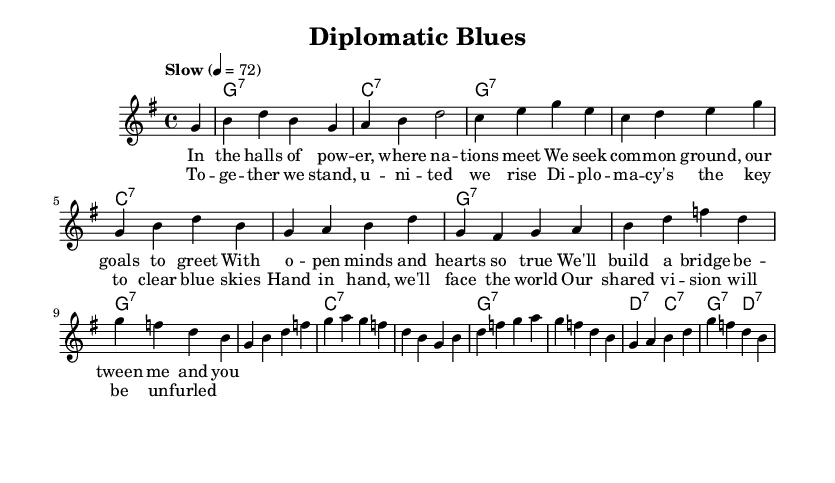What is the key signature of this music? The key signature is G major, which has one sharp (F#). You can determine this from the `\key g \major` command in the code.
Answer: G major What is the time signature of this music? The time signature is 4/4, indicated by the `\time 4/4` command in the notation. This means there are four beats per measure and the quarter note gets one beat.
Answer: 4/4 What is the tempo marking of this music? The tempo marking is "Slow" with a beat of 72, explicitly stated in the `\tempo "Slow" 4 = 72` line. This suggests a slow and relaxed pace for the performance.
Answer: Slow What is the primary theme of the lyrics? The primary theme of the lyrics revolves around cooperation and unity among nations, as indicated by phrases like "together we stand" and "build a bridge." This shows a focus on diplomatic relations and joint efforts.
Answer: Cooperation What type of chords are used in the harmonies? The harmonies primarily use seventh chords, denoted by the `:7` in the chord names (e.g., g1:7, c1:7). This indicates a jazzy feel which is characteristic of blues music.
Answer: Seventh chords How does the structure of this piece reflect typical blues progression? The structure follows a typical 12-bar blues progression, where the repeated chords create a cyclical feel, evident in the `\harmonies` section that shifts between the I, IV, and V chords common in blues.
Answer: 12-bar blues 